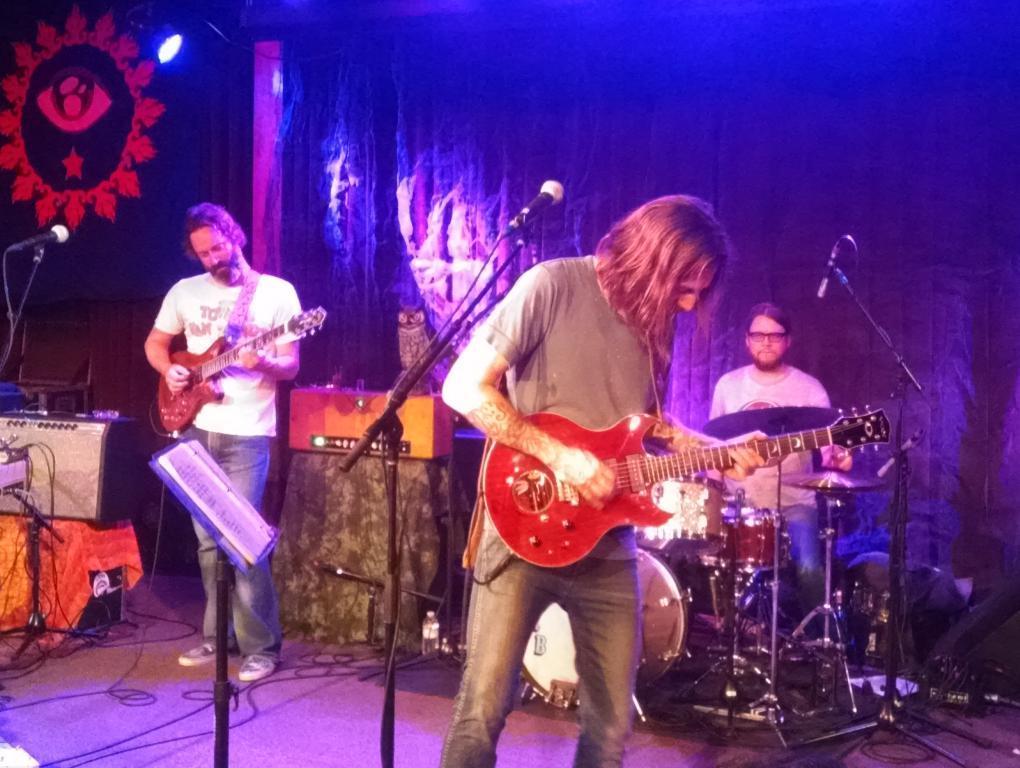Could you give a brief overview of what you see in this image? In this image I see 2 men who are standing and I see that they're holding guitars in their hands and I see the tripods on which there are mics and I see another man near to this drums and I see the wires on the platform and in the background I see the light over here and I see the curtain and I see few things over here. 